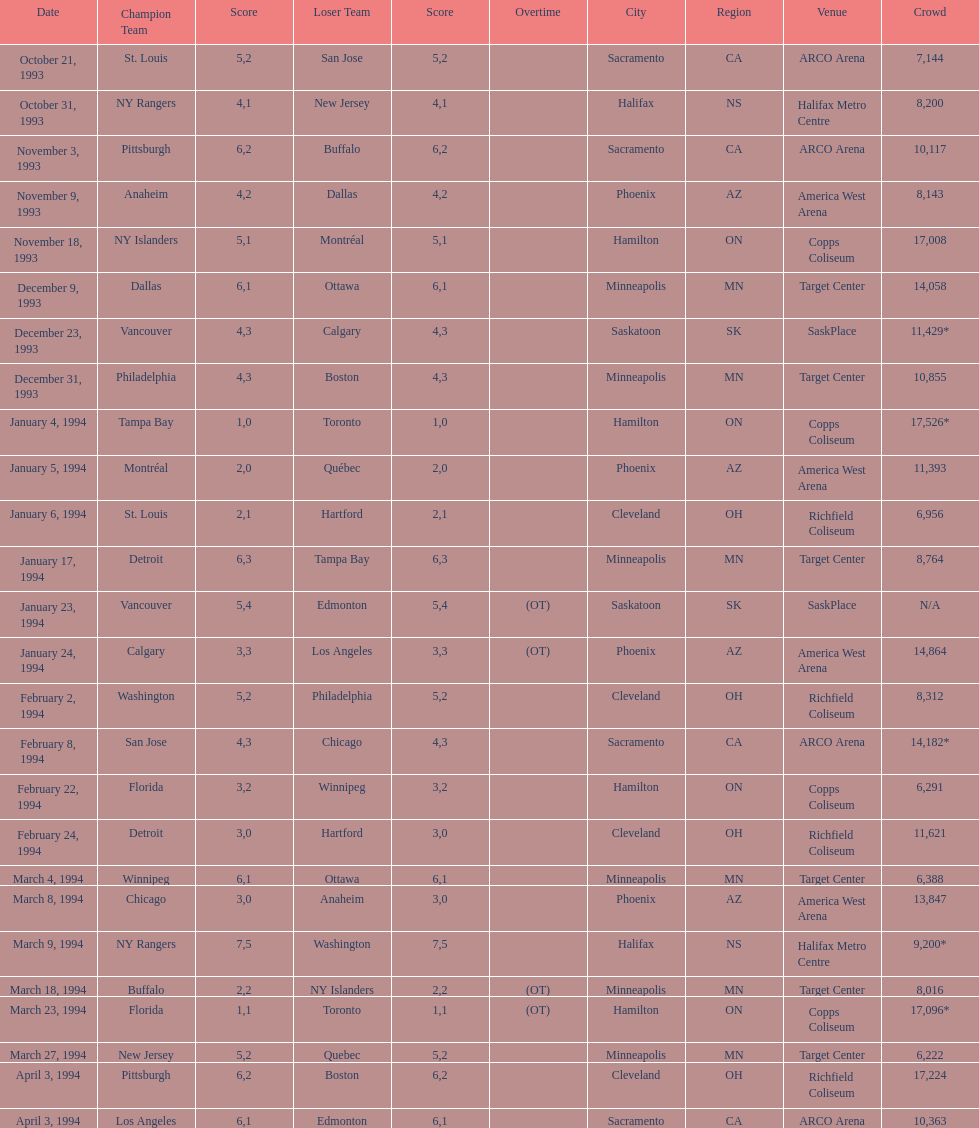How many events occurred in minneapolis, mn? 6. 